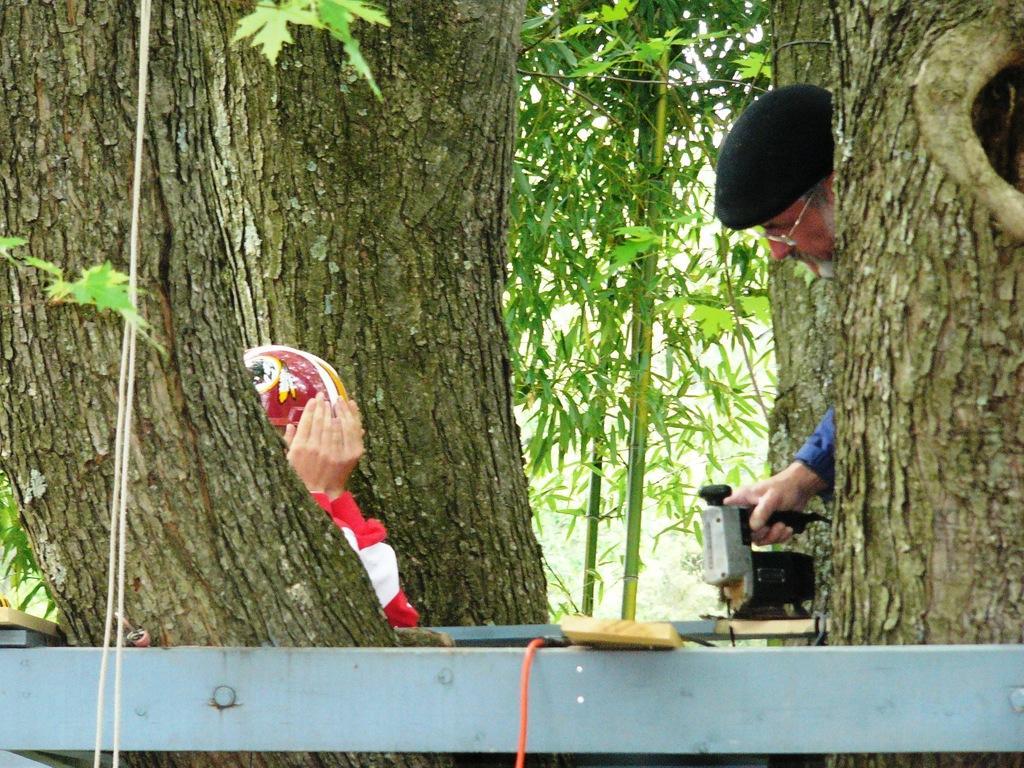Please provide a concise description of this image. This picture might be taken outside of the city. In this image, on the right side, we can see a man holding a drilling machine in his hands, we can also see some trees. On the left side, we can see a person wearing a helmet, we can see few trees. In the background, we can see a metal rod, trees. 